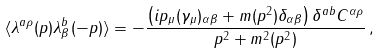Convert formula to latex. <formula><loc_0><loc_0><loc_500><loc_500>\langle \lambda ^ { a \rho } ( p ) \lambda ^ { b } _ { \beta } ( - p ) \rangle = - \frac { \left ( i p _ { \mu } ( \gamma _ { \mu } ) _ { \alpha \beta } + m ( p ^ { 2 } ) \delta _ { \alpha \beta } \right ) \delta ^ { a b } C ^ { \alpha \rho } } { p ^ { 2 } + m ^ { 2 } ( p ^ { 2 } ) } \, ,</formula> 